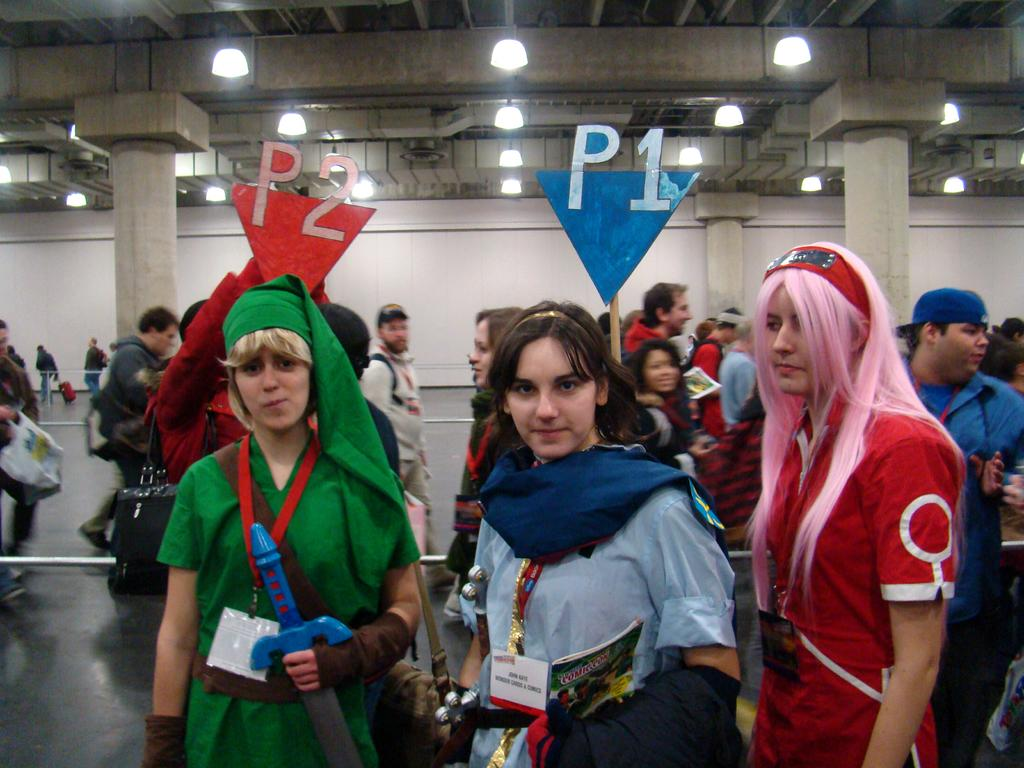What are the people in the image wearing? The people in the image are wearing costumes. What are the people holding in the image? The people are holding boards. What can be seen in the background of the image? There is a wall in the background of the image. What is visible at the top of the image? There are lights visible at the top of the image. What type of joke is being told by the person standing next to the gate in the image? There is no gate present in the image, and therefore no person standing next to it to tell a joke. 